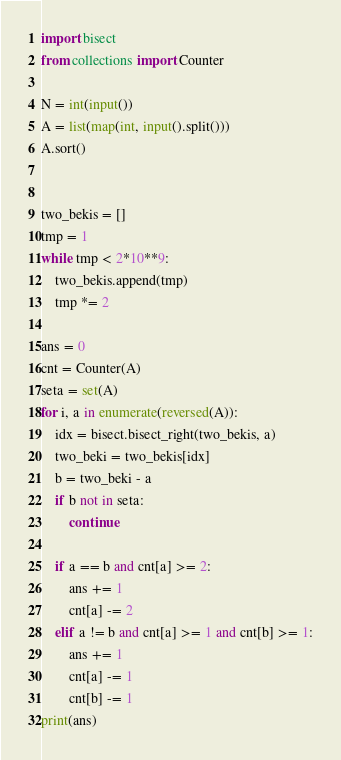<code> <loc_0><loc_0><loc_500><loc_500><_Python_>import bisect
from collections import Counter

N = int(input())
A = list(map(int, input().split()))
A.sort()


two_bekis = []
tmp = 1
while tmp < 2*10**9:
    two_bekis.append(tmp)
    tmp *= 2

ans = 0
cnt = Counter(A)
seta = set(A)
for i, a in enumerate(reversed(A)):
    idx = bisect.bisect_right(two_bekis, a)
    two_beki = two_bekis[idx]
    b = two_beki - a
    if b not in seta:
        continue

    if a == b and cnt[a] >= 2:
        ans += 1
        cnt[a] -= 2
    elif a != b and cnt[a] >= 1 and cnt[b] >= 1:
        ans += 1
        cnt[a] -= 1
        cnt[b] -= 1
print(ans)
</code> 